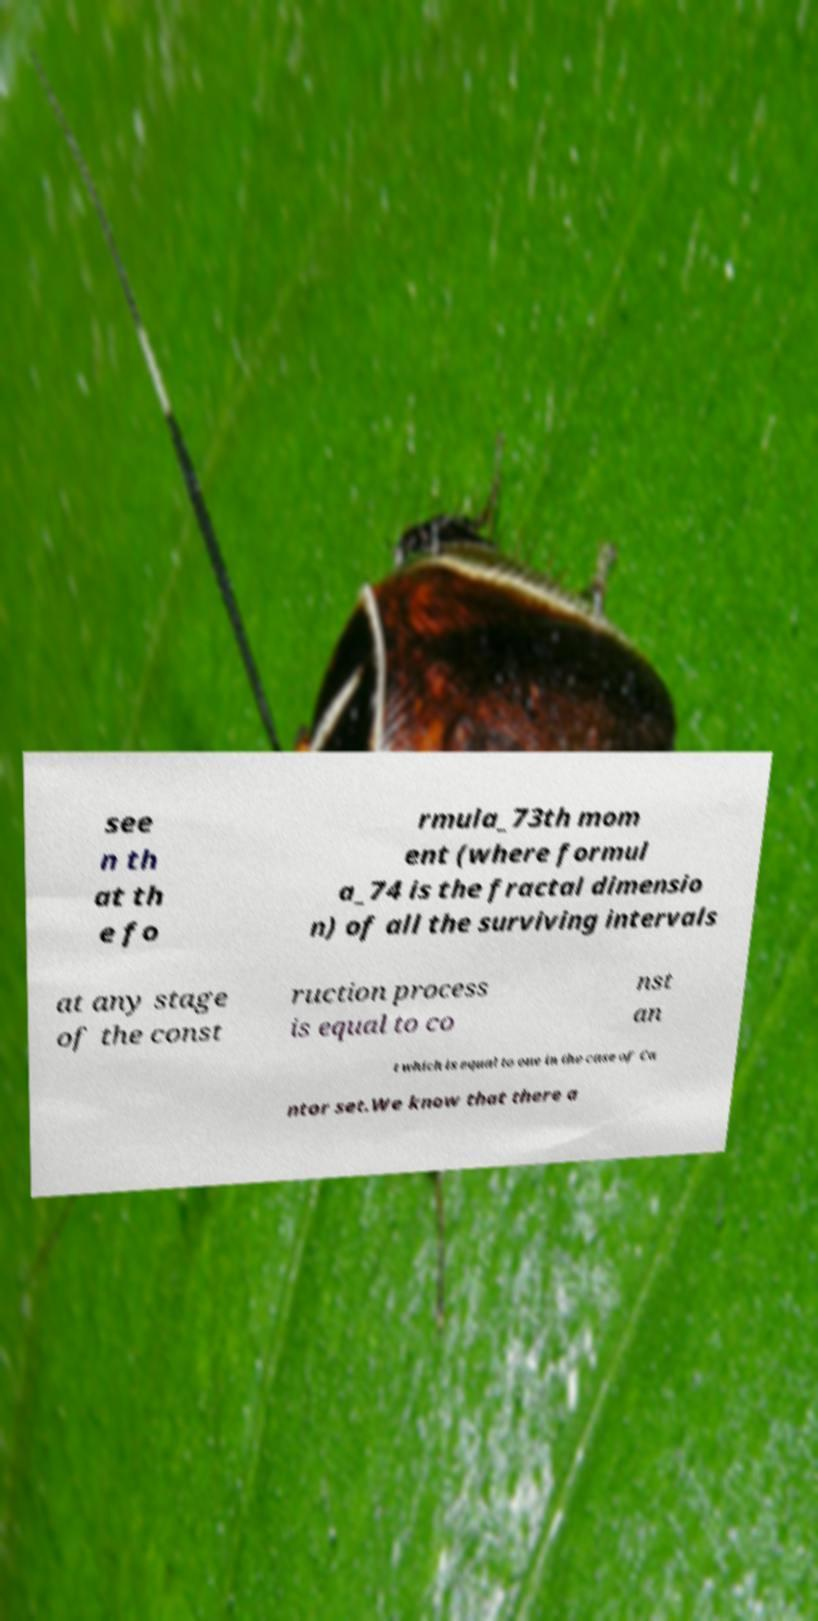Can you accurately transcribe the text from the provided image for me? see n th at th e fo rmula_73th mom ent (where formul a_74 is the fractal dimensio n) of all the surviving intervals at any stage of the const ruction process is equal to co nst an t which is equal to one in the case of Ca ntor set.We know that there a 